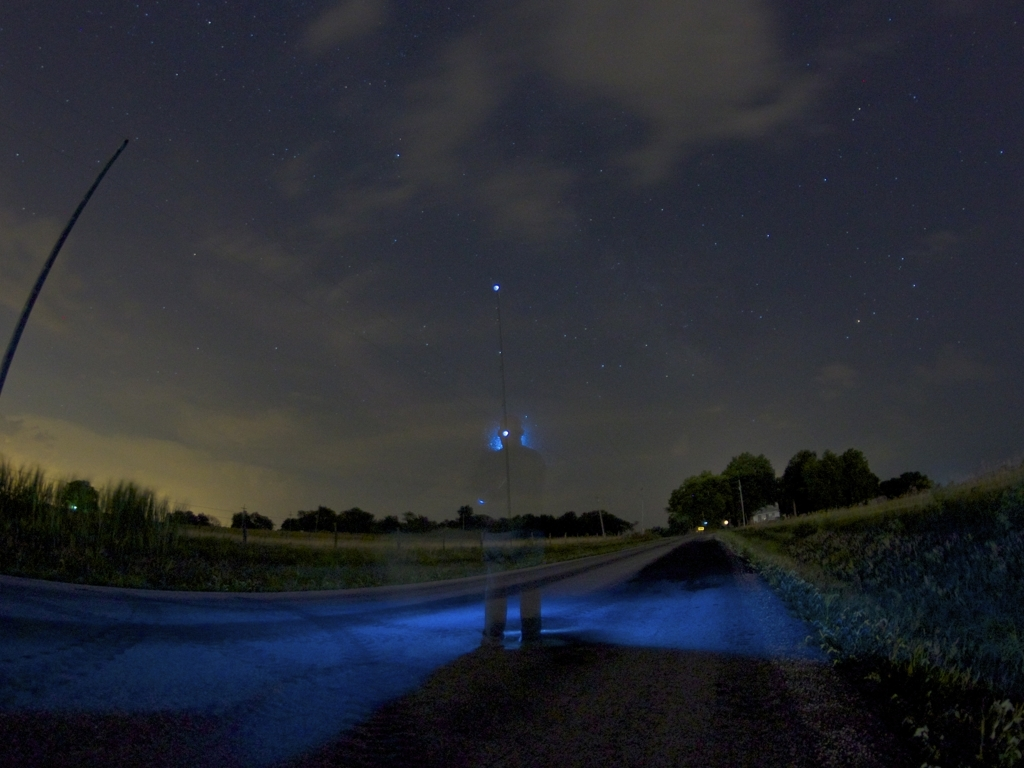Is there clear texture detail in the background and subject? The clarity of texture detail in this image is moderate; the background features a night sky with discernible cloud formations and a hint of stars, while the subject, a person with motion blur, offers a ghostly form with limited texture detail. So, it's a blend of clearer textures in the sky and less defined details in the subject. 